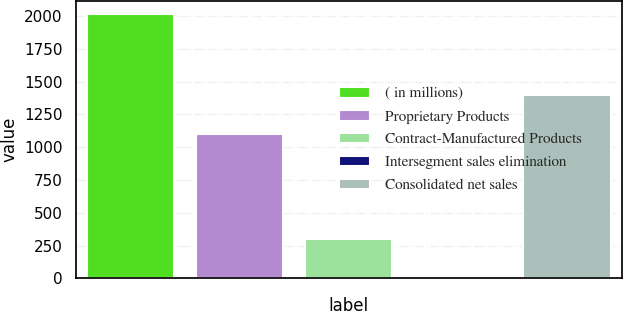Convert chart. <chart><loc_0><loc_0><loc_500><loc_500><bar_chart><fcel>( in millions)<fcel>Proprietary Products<fcel>Contract-Manufactured Products<fcel>Intersegment sales elimination<fcel>Consolidated net sales<nl><fcel>2015<fcel>1098.3<fcel>302.4<fcel>0.9<fcel>1399.8<nl></chart> 